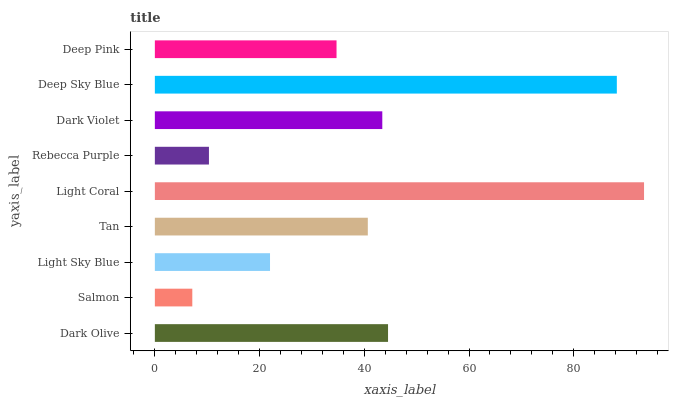Is Salmon the minimum?
Answer yes or no. Yes. Is Light Coral the maximum?
Answer yes or no. Yes. Is Light Sky Blue the minimum?
Answer yes or no. No. Is Light Sky Blue the maximum?
Answer yes or no. No. Is Light Sky Blue greater than Salmon?
Answer yes or no. Yes. Is Salmon less than Light Sky Blue?
Answer yes or no. Yes. Is Salmon greater than Light Sky Blue?
Answer yes or no. No. Is Light Sky Blue less than Salmon?
Answer yes or no. No. Is Tan the high median?
Answer yes or no. Yes. Is Tan the low median?
Answer yes or no. Yes. Is Dark Olive the high median?
Answer yes or no. No. Is Deep Sky Blue the low median?
Answer yes or no. No. 